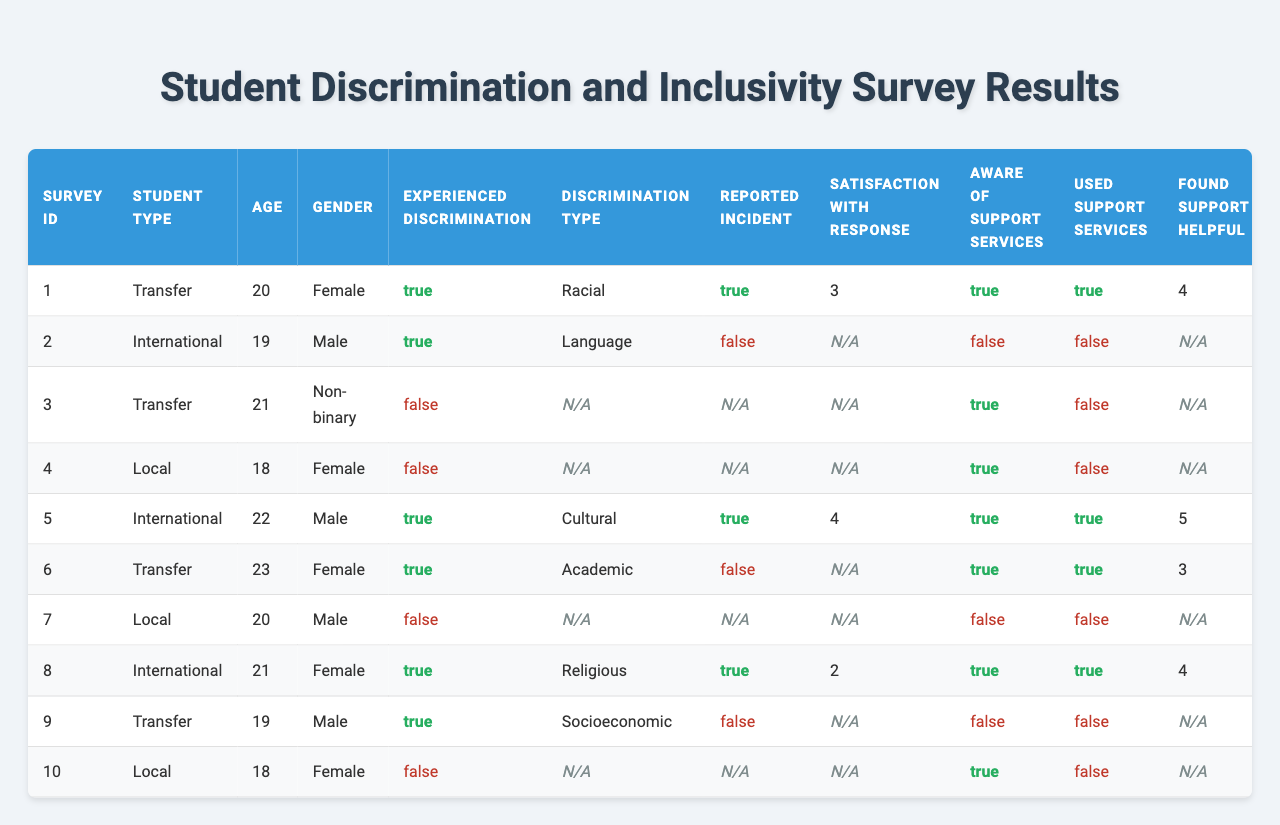What percentage of transfer students experienced discrimination? Out of the 5 transfer students, 4 experienced discrimination. To find the percentage, (4/5) * 100 = 80%.
Answer: 80% What type of discrimination is most frequently reported among international students? Among the 3 international students, 2 reported discrimination: 1 for language and 1 for cultural. Therefore, there is no clear most frequent type since there are two different types reported.
Answer: None Did any local students report experiencing discrimination? The table shows that 3 local students did not experience discrimination, which indicates that none experienced it.
Answer: No What is the average satisfaction rating with the response among students who experienced discrimination? The ratings from students who experienced discrimination are 3, 4, 3, and 2. The average is (3 + 4 + 3 + 2) / 4 = 3.
Answer: 3 How many students were aware of support services but did not use them? Among the students aware of support services, 2 did not use them. Those students are Transfer Student ID 3 and Local Student ID 4.
Answer: 2 Is there a correlation between participating in inclusivity programs and feeling included on campus among transfer students? All transfer students who participated in inclusivity programs (Transfer Student IDs 1, 3, and 9) have scores of 3, 4, and 2 for feeling included on campus, while the transfer students who did not (Transfer Student IDs 2, 5, and 7) have scores of 5, 3. However, the sample is small, and there is no definitive pattern since feelings of inclusion vary.
Answer: No clear correlation Which gender had the most number of reported incidents of discrimination? Female students experienced discrimination in 3 of the 5 reported cases. Therefore, females had the most reported incidents of discrimination.
Answer: Female What is the total number of reported incidents across all student types? The total number of reported incidents is 5, coming from Transfer Student IDs 1, 5, 8 and International Student IDs 1, 4. Local students reported no incidents.
Answer: 5 What is the average age of students who found support helpful? The ages of students who found support helpful are 20 (from Student ID 1), 22 (from Student ID 5), and 21 (from Student ID 8). The average is (20 + 22 + 21) / 3 = 21.
Answer: 21 How many students recommend inclusivity improvements and also feel included on campus? The students who recommend inclusivity improvements and feel included are Transfer Student IDs 1, 5, 9, and 7. This totals to 4 students.
Answer: 4 